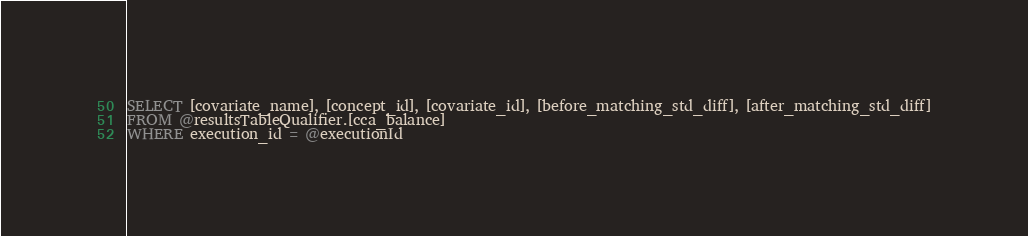Convert code to text. <code><loc_0><loc_0><loc_500><loc_500><_SQL_>SELECT [covariate_name], [concept_id], [covariate_id], [before_matching_std_diff], [after_matching_std_diff]
FROM @resultsTableQualifier.[cca_balance] 
WHERE execution_id = @executionId</code> 